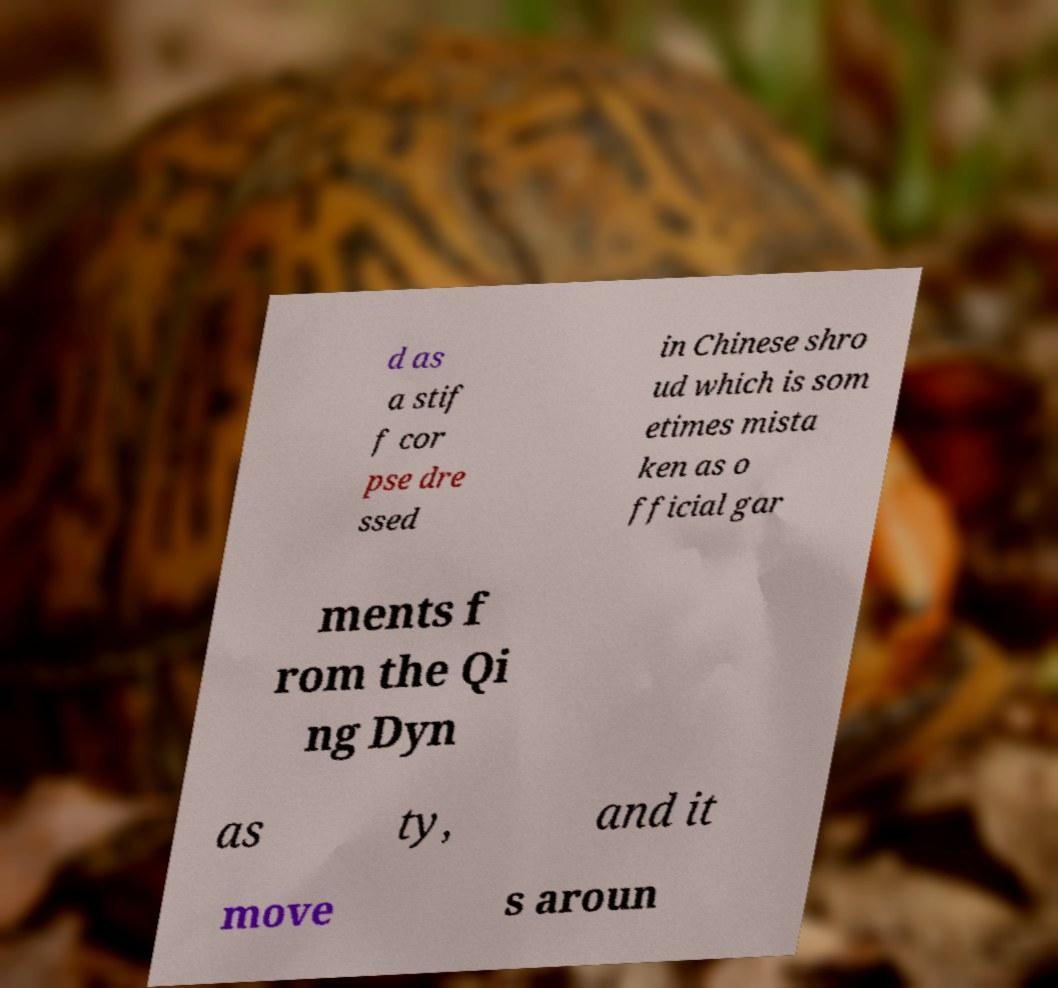What messages or text are displayed in this image? I need them in a readable, typed format. d as a stif f cor pse dre ssed in Chinese shro ud which is som etimes mista ken as o fficial gar ments f rom the Qi ng Dyn as ty, and it move s aroun 